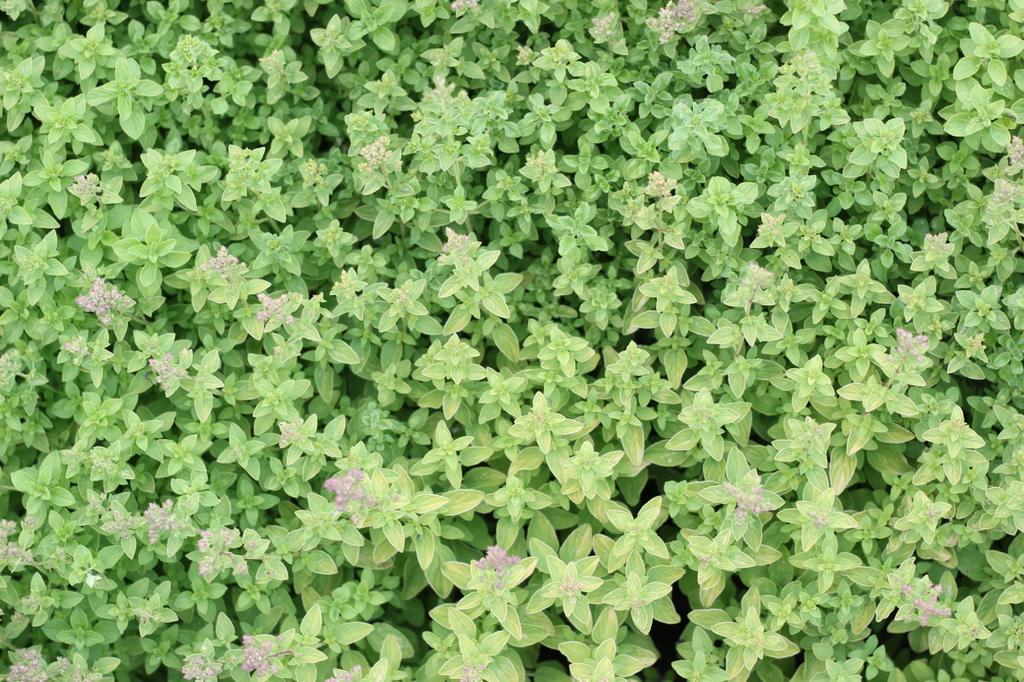What type of living organisms can be seen in the image? Plants can be seen in the image. What color are the leaves of the plants in the image? The leaves of the plants in the image are green. What additional features can be observed on some of the plants? Some of the plants have flowers. Can you see a deer running through the plants in the image? No, there is no deer or any running activity present in the image; it only features plants with green leaves and some with flowers. 